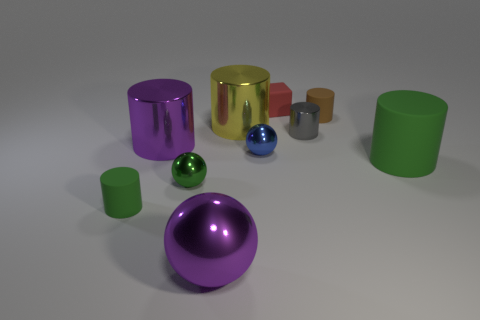Subtract all large yellow cylinders. How many cylinders are left? 5 Subtract 3 cylinders. How many cylinders are left? 3 Subtract all purple cylinders. How many cylinders are left? 5 Subtract all brown cubes. Subtract all brown spheres. How many cubes are left? 1 Subtract all gray balls. How many yellow cylinders are left? 1 Add 6 big yellow metal objects. How many big yellow metal objects are left? 7 Add 5 large purple metallic cylinders. How many large purple metallic cylinders exist? 6 Subtract 0 gray balls. How many objects are left? 10 Subtract all spheres. How many objects are left? 7 Subtract all gray metal things. Subtract all tiny green matte cylinders. How many objects are left? 8 